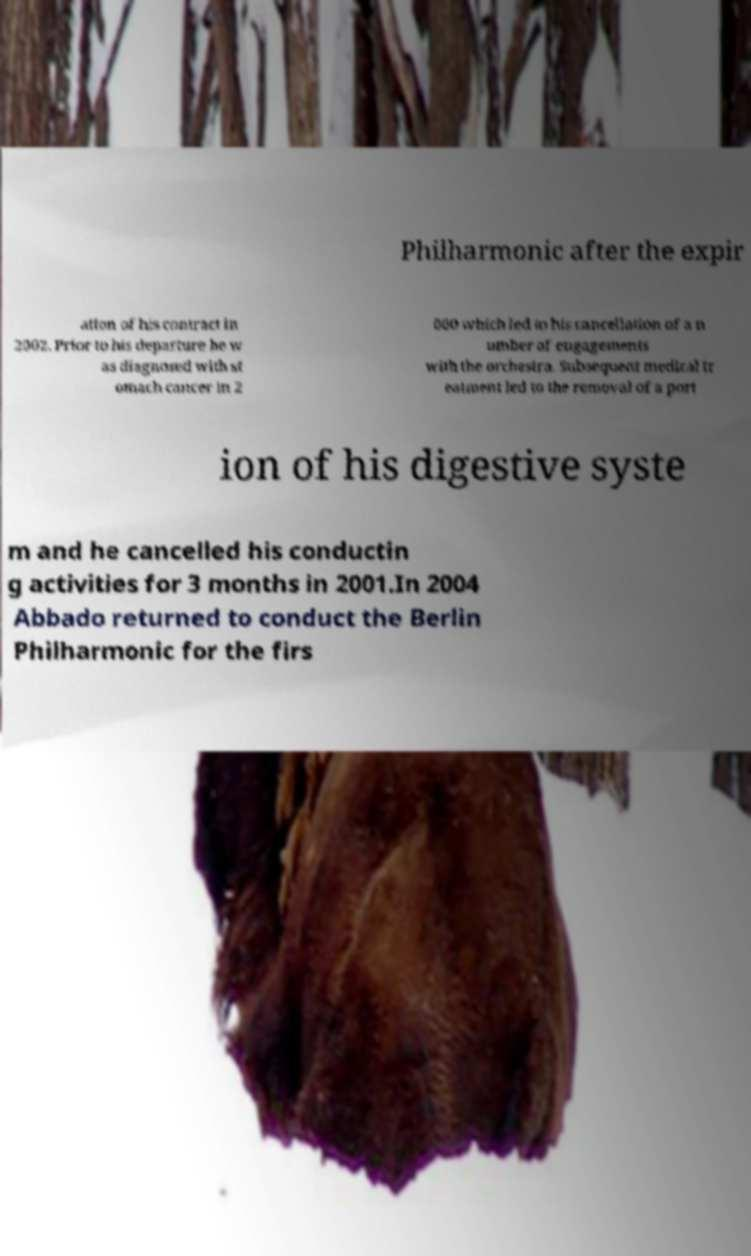What messages or text are displayed in this image? I need them in a readable, typed format. Philharmonic after the expir ation of his contract in 2002. Prior to his departure he w as diagnosed with st omach cancer in 2 000 which led to his cancellation of a n umber of engagements with the orchestra. Subsequent medical tr eatment led to the removal of a port ion of his digestive syste m and he cancelled his conductin g activities for 3 months in 2001.In 2004 Abbado returned to conduct the Berlin Philharmonic for the firs 